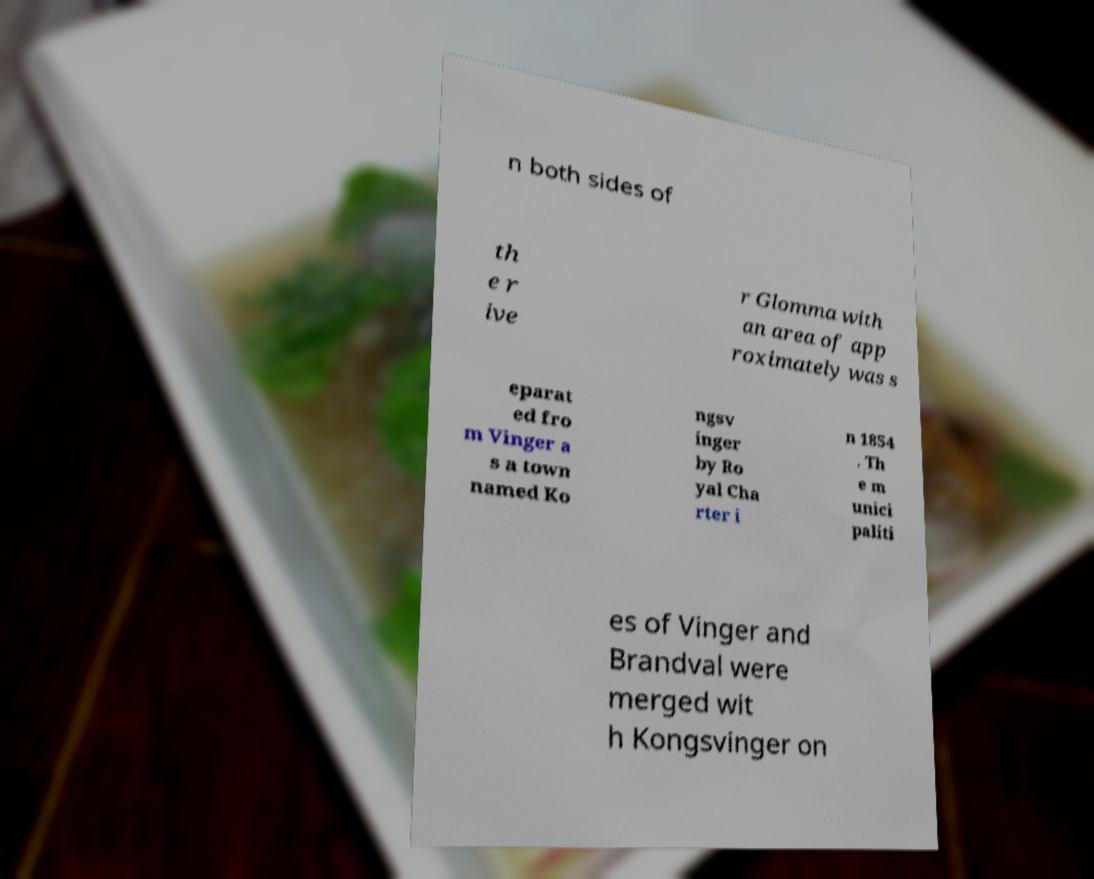What messages or text are displayed in this image? I need them in a readable, typed format. n both sides of th e r ive r Glomma with an area of app roximately was s eparat ed fro m Vinger a s a town named Ko ngsv inger by Ro yal Cha rter i n 1854 . Th e m unici paliti es of Vinger and Brandval were merged wit h Kongsvinger on 